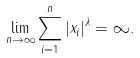<formula> <loc_0><loc_0><loc_500><loc_500>\lim _ { n \to \infty } \sum _ { i = 1 } ^ { n } | x _ { i } | ^ { \lambda } = \infty .</formula> 